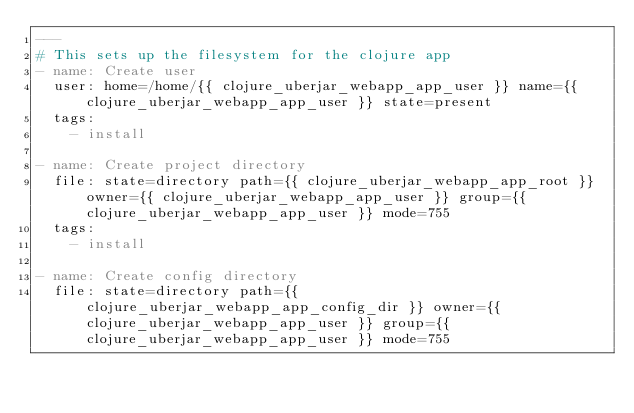Convert code to text. <code><loc_0><loc_0><loc_500><loc_500><_YAML_>---
# This sets up the filesystem for the clojure app
- name: Create user
  user: home=/home/{{ clojure_uberjar_webapp_app_user }} name={{ clojure_uberjar_webapp_app_user }} state=present
  tags:
    - install

- name: Create project directory
  file: state=directory path={{ clojure_uberjar_webapp_app_root }} owner={{ clojure_uberjar_webapp_app_user }} group={{ clojure_uberjar_webapp_app_user }} mode=755
  tags:
    - install

- name: Create config directory
  file: state=directory path={{ clojure_uberjar_webapp_app_config_dir }} owner={{ clojure_uberjar_webapp_app_user }} group={{ clojure_uberjar_webapp_app_user }} mode=755</code> 